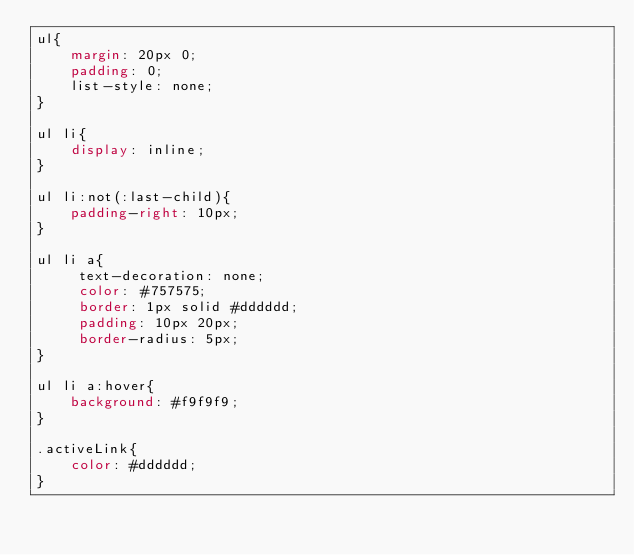Convert code to text. <code><loc_0><loc_0><loc_500><loc_500><_CSS_>ul{
    margin: 20px 0;
    padding: 0;
    list-style: none;
}

ul li{
    display: inline;
}

ul li:not(:last-child){
    padding-right: 10px;
}

ul li a{
     text-decoration: none;
     color: #757575;
     border: 1px solid #dddddd;
     padding: 10px 20px;
     border-radius: 5px;
}

ul li a:hover{
    background: #f9f9f9;
}

.activeLink{
    color: #dddddd;
}</code> 